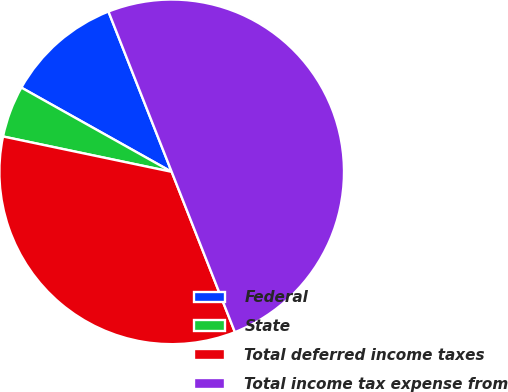<chart> <loc_0><loc_0><loc_500><loc_500><pie_chart><fcel>Federal<fcel>State<fcel>Total deferred income taxes<fcel>Total income tax expense from<nl><fcel>10.89%<fcel>4.84%<fcel>34.27%<fcel>50.0%<nl></chart> 